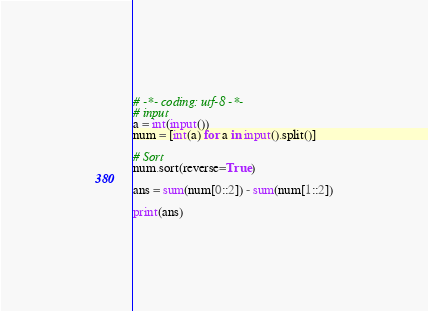Convert code to text. <code><loc_0><loc_0><loc_500><loc_500><_Python_># -*- coding: utf-8 -*-
# input
a = int(input())
num = [int(a) for a in input().split()]

# Sort
num.sort(reverse=True)

ans = sum(num[0::2]) - sum(num[1::2])

print(ans)
</code> 